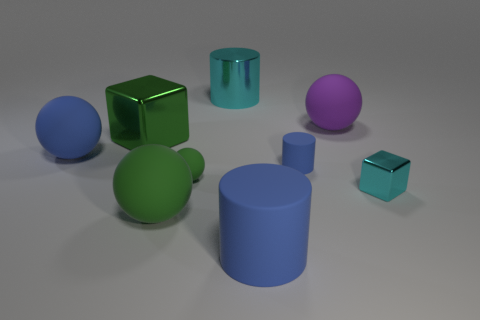Subtract 1 spheres. How many spheres are left? 3 Add 1 big purple spheres. How many objects exist? 10 Subtract all cubes. How many objects are left? 7 Add 2 large green metal things. How many large green metal things exist? 3 Subtract 1 cyan cubes. How many objects are left? 8 Subtract all small green spheres. Subtract all tiny rubber objects. How many objects are left? 6 Add 3 big purple objects. How many big purple objects are left? 4 